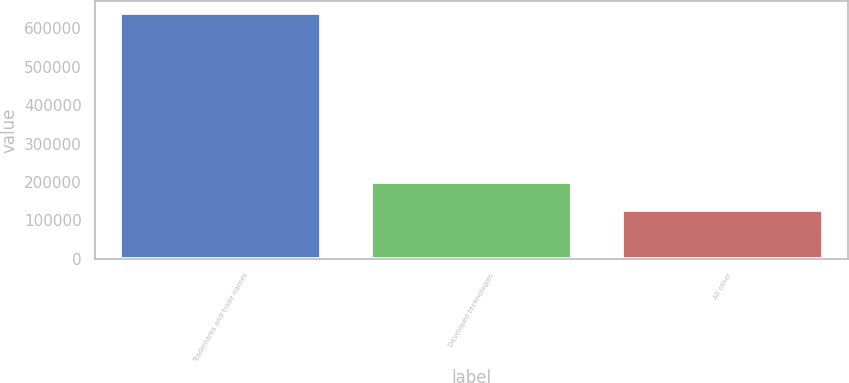<chart> <loc_0><loc_0><loc_500><loc_500><bar_chart><fcel>Trademarks and trade names<fcel>Developed technologies<fcel>All other<nl><fcel>638930<fcel>199893<fcel>126381<nl></chart> 